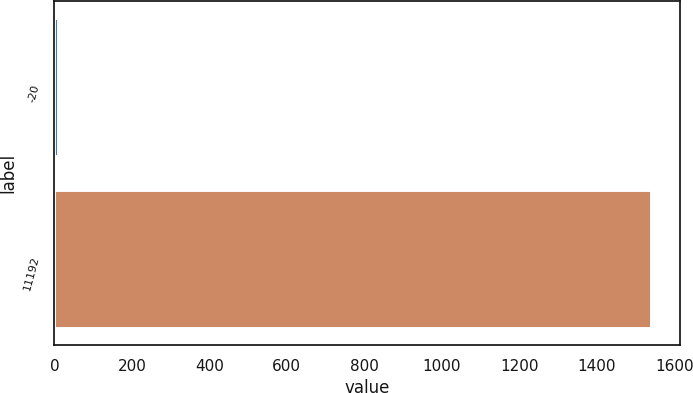<chart> <loc_0><loc_0><loc_500><loc_500><bar_chart><fcel>-20<fcel>11192<nl><fcel>10<fcel>1539<nl></chart> 